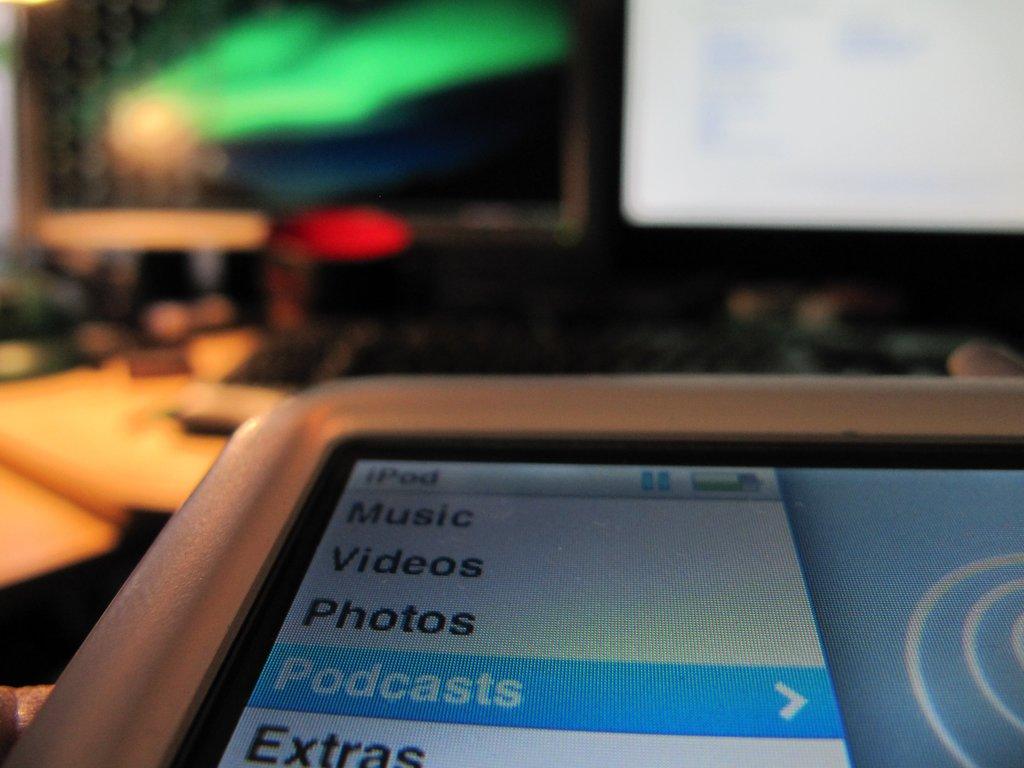Are they listening to a podcast?
Offer a very short reply. Yes. What is listed right below podcasts?
Provide a short and direct response. Extras. 